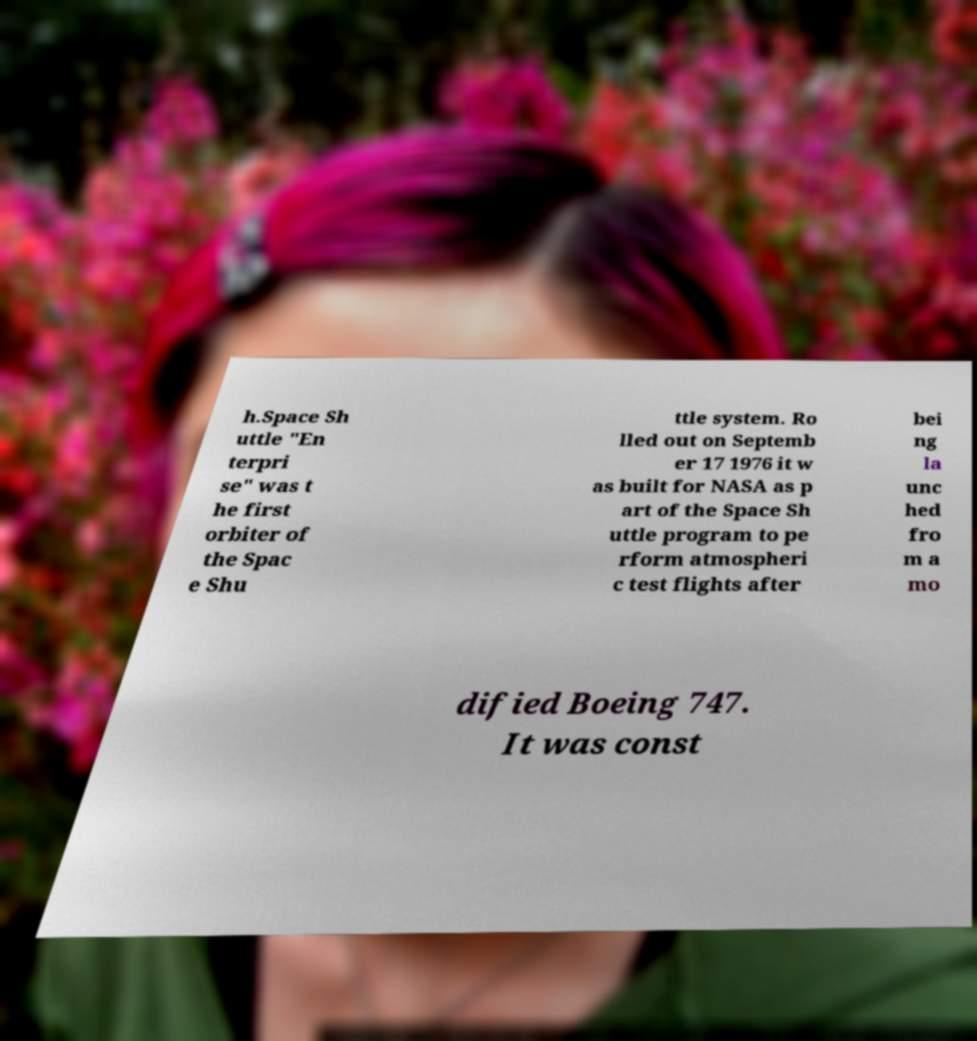Please read and relay the text visible in this image. What does it say? h.Space Sh uttle "En terpri se" was t he first orbiter of the Spac e Shu ttle system. Ro lled out on Septemb er 17 1976 it w as built for NASA as p art of the Space Sh uttle program to pe rform atmospheri c test flights after bei ng la unc hed fro m a mo dified Boeing 747. It was const 